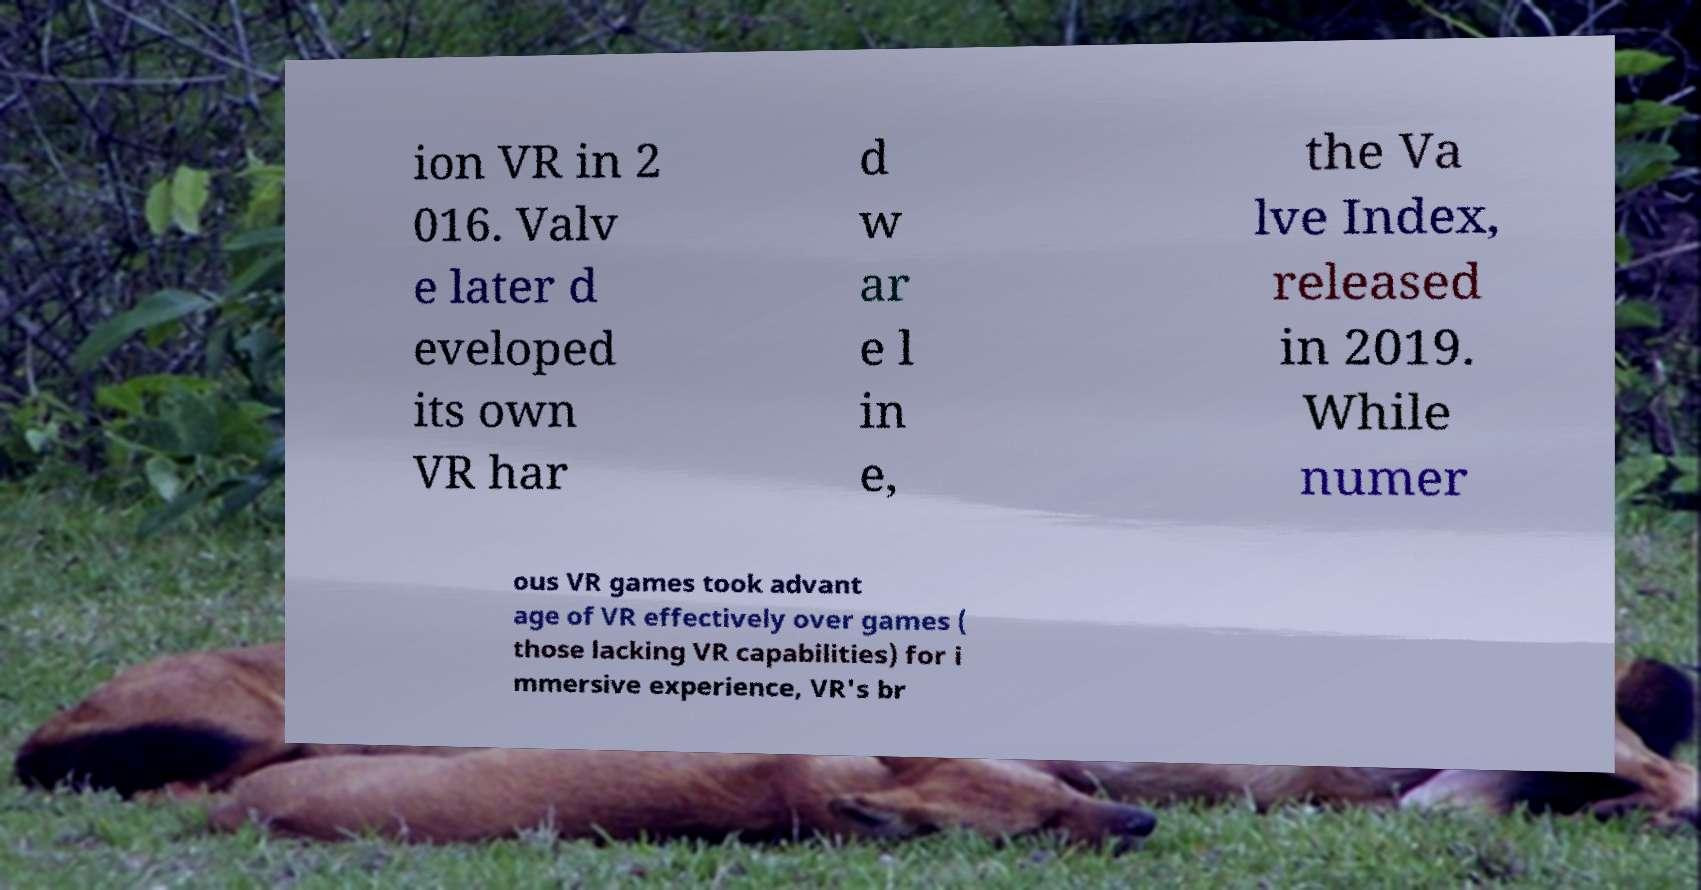Can you accurately transcribe the text from the provided image for me? ion VR in 2 016. Valv e later d eveloped its own VR har d w ar e l in e, the Va lve Index, released in 2019. While numer ous VR games took advant age of VR effectively over games ( those lacking VR capabilities) for i mmersive experience, VR's br 